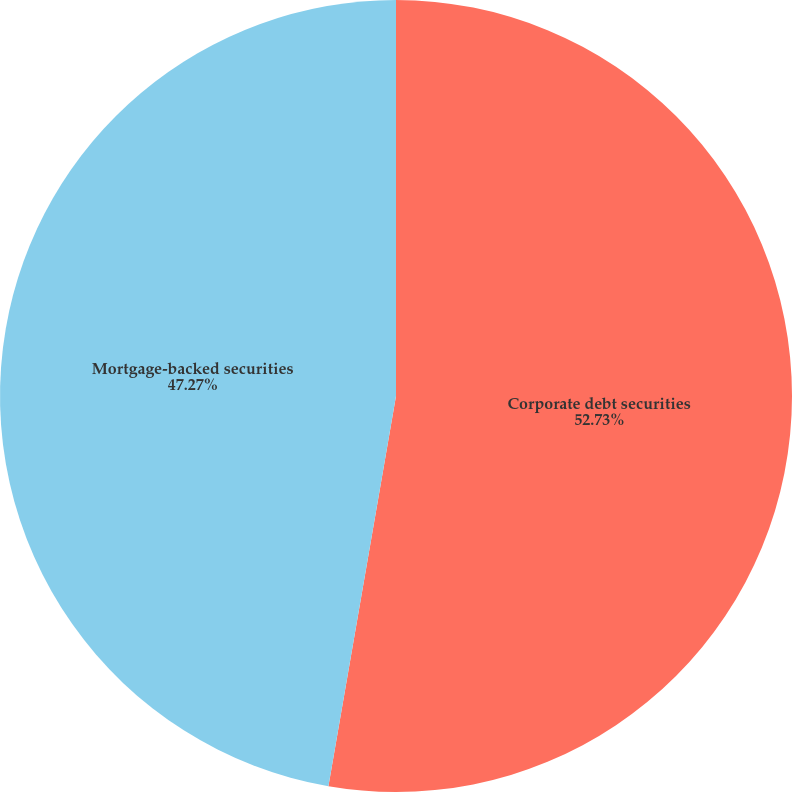Convert chart to OTSL. <chart><loc_0><loc_0><loc_500><loc_500><pie_chart><fcel>Corporate debt securities<fcel>Mortgage-backed securities<nl><fcel>52.73%<fcel>47.27%<nl></chart> 